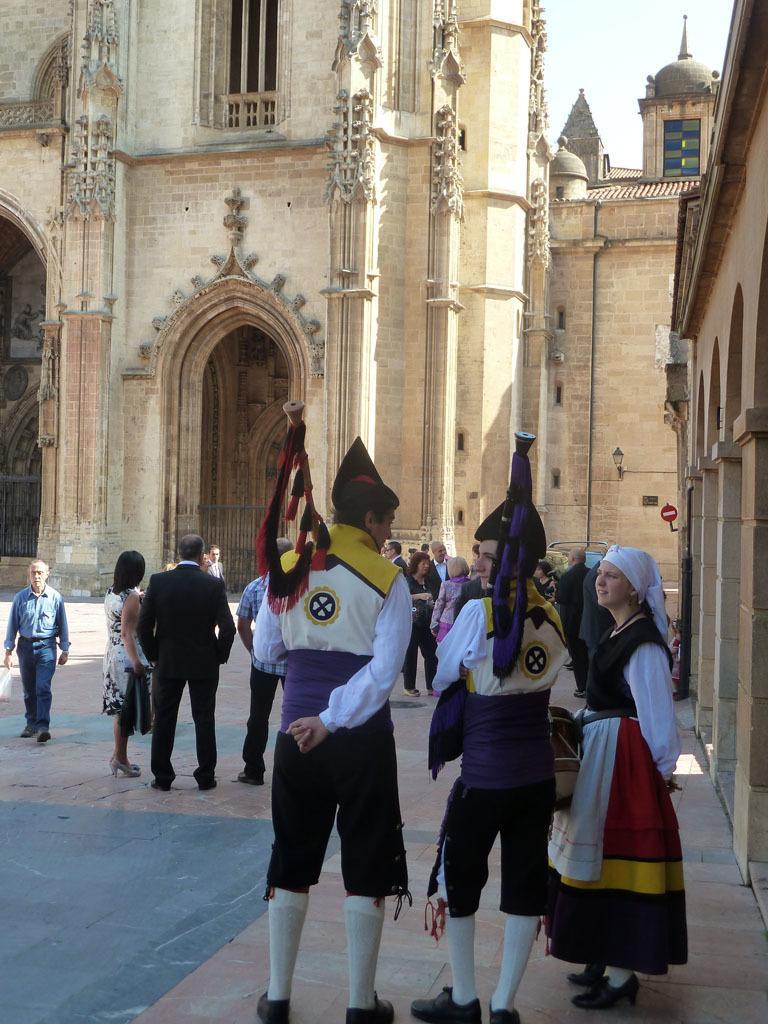Please provide a concise description of this image. In this image we can see a crowd standing on the floor and some of them are holding flags in their hands. In the background we can see buildings and sky. 